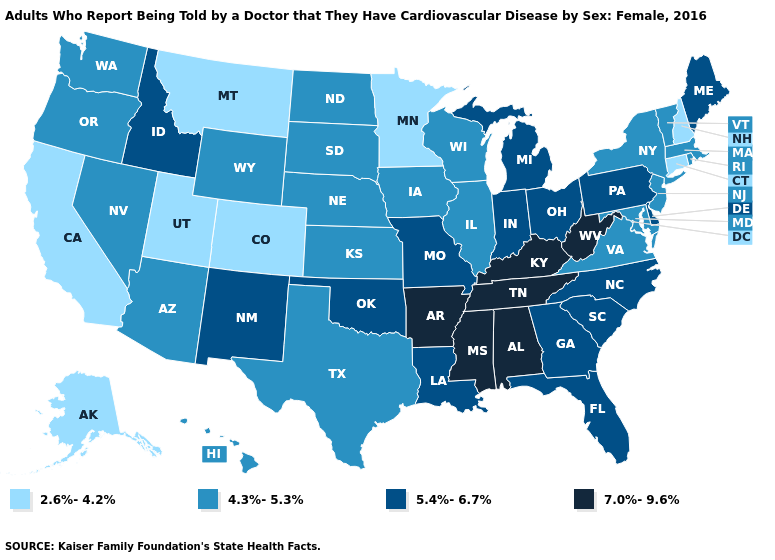Among the states that border Rhode Island , does Massachusetts have the lowest value?
Concise answer only. No. What is the value of Nevada?
Concise answer only. 4.3%-5.3%. What is the value of Nevada?
Quick response, please. 4.3%-5.3%. What is the lowest value in the USA?
Answer briefly. 2.6%-4.2%. What is the highest value in the USA?
Keep it brief. 7.0%-9.6%. Name the states that have a value in the range 5.4%-6.7%?
Keep it brief. Delaware, Florida, Georgia, Idaho, Indiana, Louisiana, Maine, Michigan, Missouri, New Mexico, North Carolina, Ohio, Oklahoma, Pennsylvania, South Carolina. Name the states that have a value in the range 2.6%-4.2%?
Keep it brief. Alaska, California, Colorado, Connecticut, Minnesota, Montana, New Hampshire, Utah. Does Kentucky have the highest value in the USA?
Quick response, please. Yes. What is the highest value in states that border Nevada?
Write a very short answer. 5.4%-6.7%. Does Mississippi have the same value as Kansas?
Concise answer only. No. What is the value of Connecticut?
Give a very brief answer. 2.6%-4.2%. Name the states that have a value in the range 4.3%-5.3%?
Keep it brief. Arizona, Hawaii, Illinois, Iowa, Kansas, Maryland, Massachusetts, Nebraska, Nevada, New Jersey, New York, North Dakota, Oregon, Rhode Island, South Dakota, Texas, Vermont, Virginia, Washington, Wisconsin, Wyoming. What is the value of Indiana?
Be succinct. 5.4%-6.7%. Which states have the lowest value in the West?
Short answer required. Alaska, California, Colorado, Montana, Utah. Among the states that border Oklahoma , does Arkansas have the highest value?
Concise answer only. Yes. 